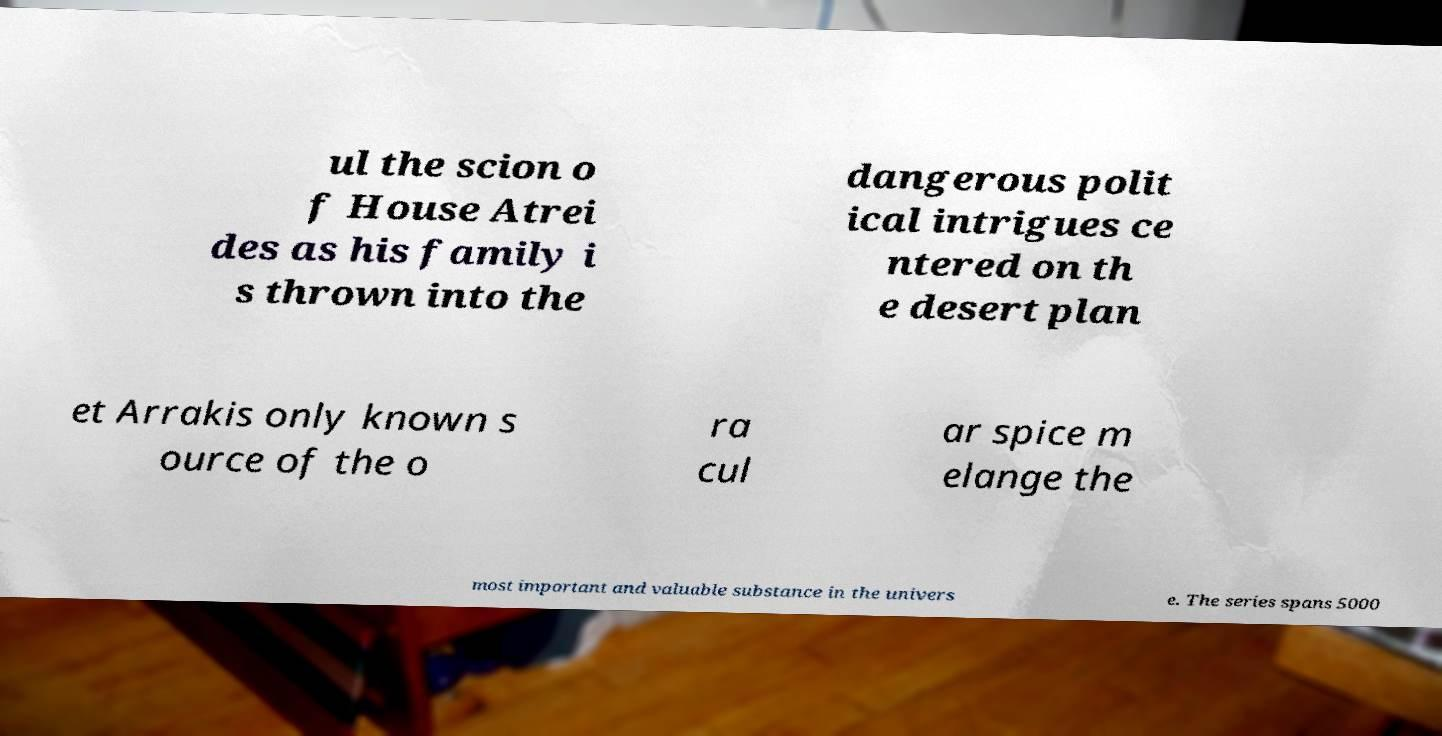Please identify and transcribe the text found in this image. ul the scion o f House Atrei des as his family i s thrown into the dangerous polit ical intrigues ce ntered on th e desert plan et Arrakis only known s ource of the o ra cul ar spice m elange the most important and valuable substance in the univers e. The series spans 5000 